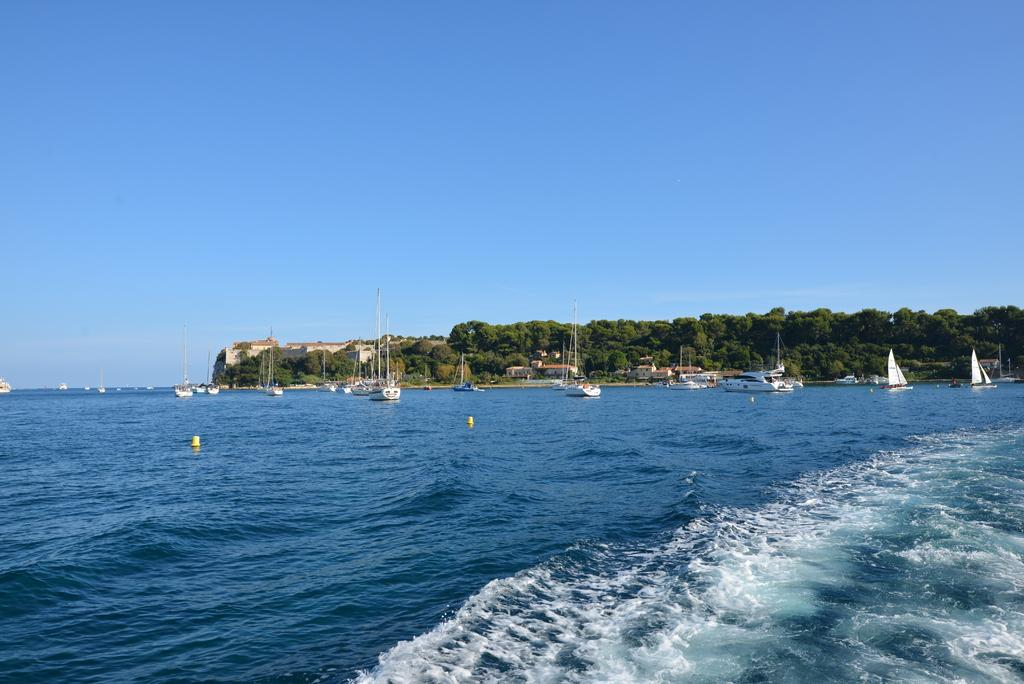What is located on the water in the image? There are boats on the water in the image. What type of vegetation can be seen in the image? There are trees visible in the image. What type of structure is present in the image? There is a building in the image. What is visible at the top of the image? The sky is visible at the top of the image. What is present at the bottom of the image? Water is present at the bottom of the image. What type of song is being sung by the boats in the image? There is no indication in the image that the boats are singing a song. What type of plough is being used to cultivate the water in the image? There is no plough present in the image, and water cannot be cultivated like soil. 